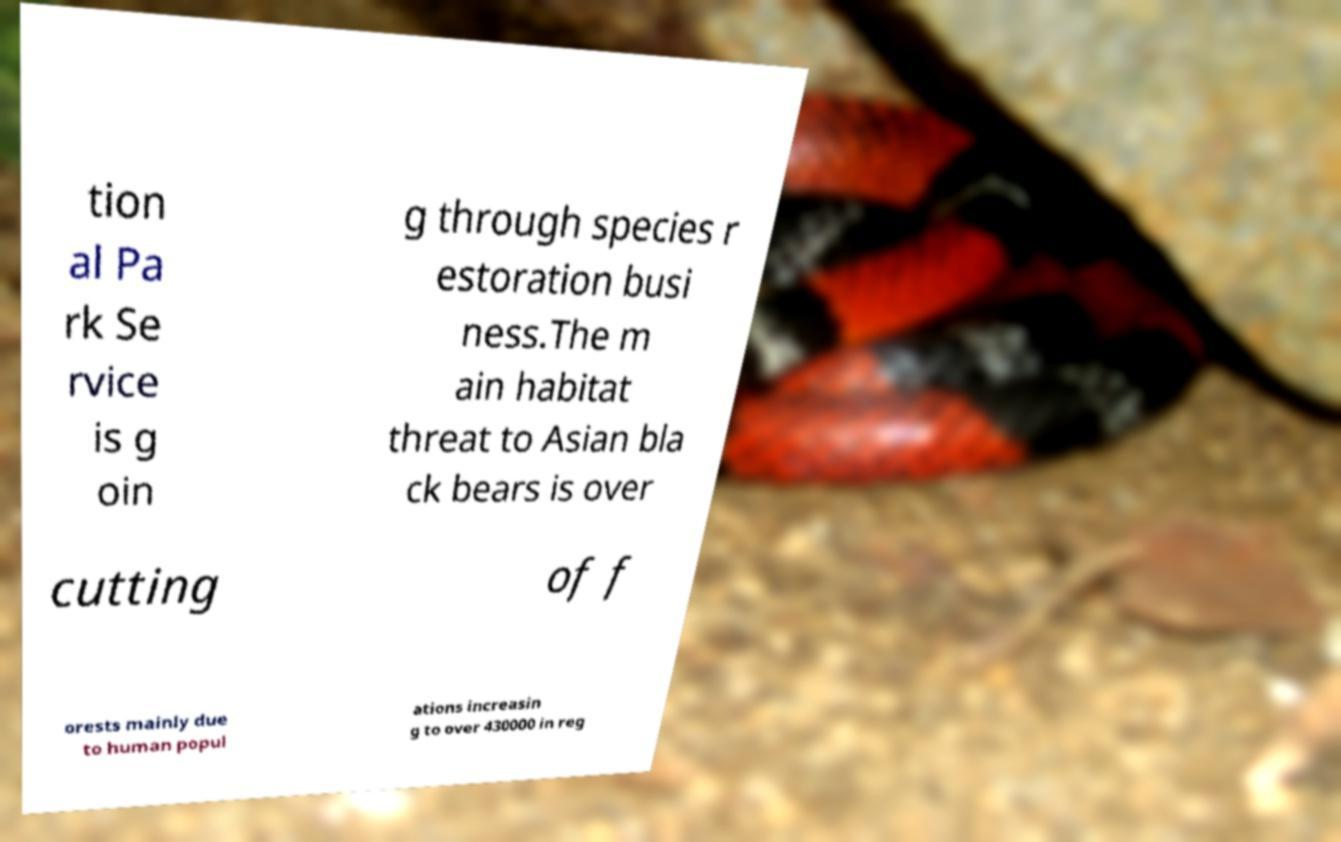Could you extract and type out the text from this image? tion al Pa rk Se rvice is g oin g through species r estoration busi ness.The m ain habitat threat to Asian bla ck bears is over cutting of f orests mainly due to human popul ations increasin g to over 430000 in reg 